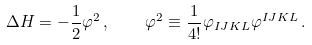Convert formula to latex. <formula><loc_0><loc_0><loc_500><loc_500>\Delta H = - \frac { 1 } { 2 } \varphi ^ { 2 } \, , \quad \varphi ^ { 2 } \equiv \frac { 1 } { 4 ! } \varphi _ { I J K L } \varphi ^ { I J K L } \, .</formula> 